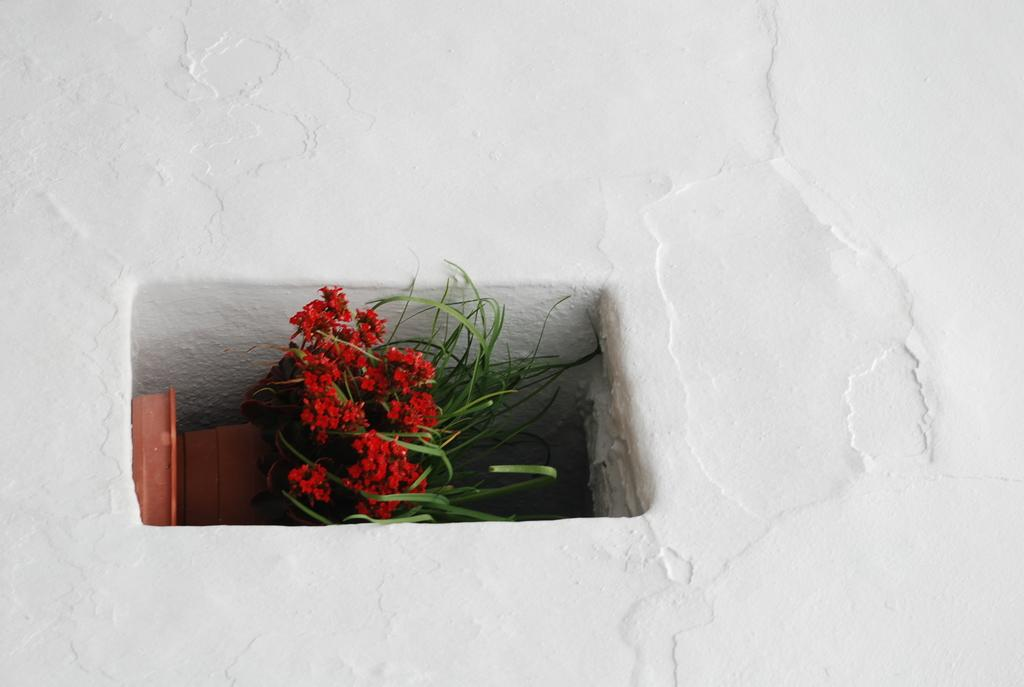What type of plant can be seen in the image? There is a house plant in the image. What color are the flowers on the house plant? The house plant has red flowers. Where is the house plant located in the image? The house plant is placed inside a wall. How many lines can be seen on the calculator in the image? There is no calculator present in the image, so it is not possible to determine the number of lines on it. 